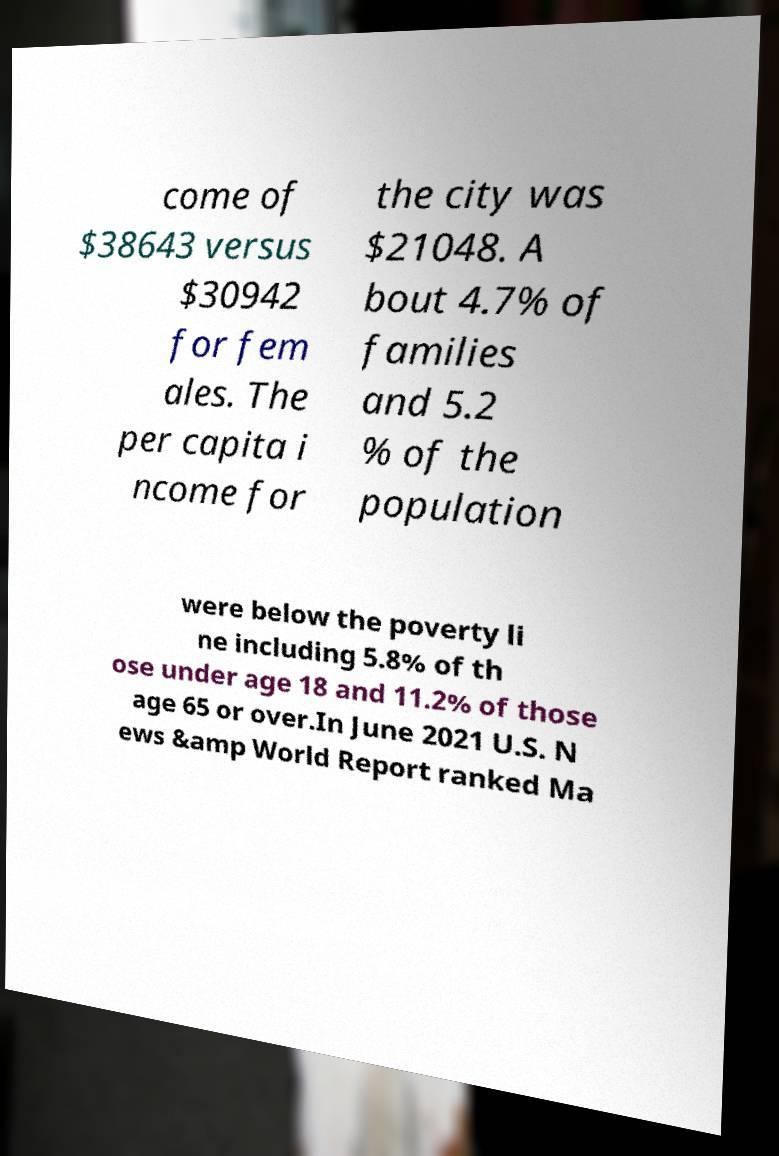Please read and relay the text visible in this image. What does it say? come of $38643 versus $30942 for fem ales. The per capita i ncome for the city was $21048. A bout 4.7% of families and 5.2 % of the population were below the poverty li ne including 5.8% of th ose under age 18 and 11.2% of those age 65 or over.In June 2021 U.S. N ews &amp World Report ranked Ma 